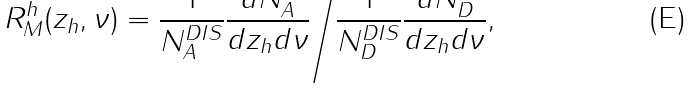<formula> <loc_0><loc_0><loc_500><loc_500>R _ { M } ^ { h } ( z _ { h } , \nu ) = \frac { 1 } { N _ { A } ^ { D I S } } \frac { d N _ { A } ^ { h } } { d z _ { h } d \nu } \Big { / } \frac { 1 } { N _ { D } ^ { D I S } } \frac { d N _ { D } ^ { h } } { d z _ { h } d \nu } , \</formula> 